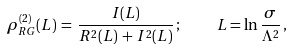Convert formula to latex. <formula><loc_0><loc_0><loc_500><loc_500>\rho _ { R G } ^ { ( 2 ) } ( L ) \, = \, \frac { I ( L ) } { R ^ { 2 } ( L ) \, + \, I ^ { 2 } ( L ) } \, ; \quad L = \ln \frac { \sigma } { \Lambda ^ { 2 } } \, ,</formula> 